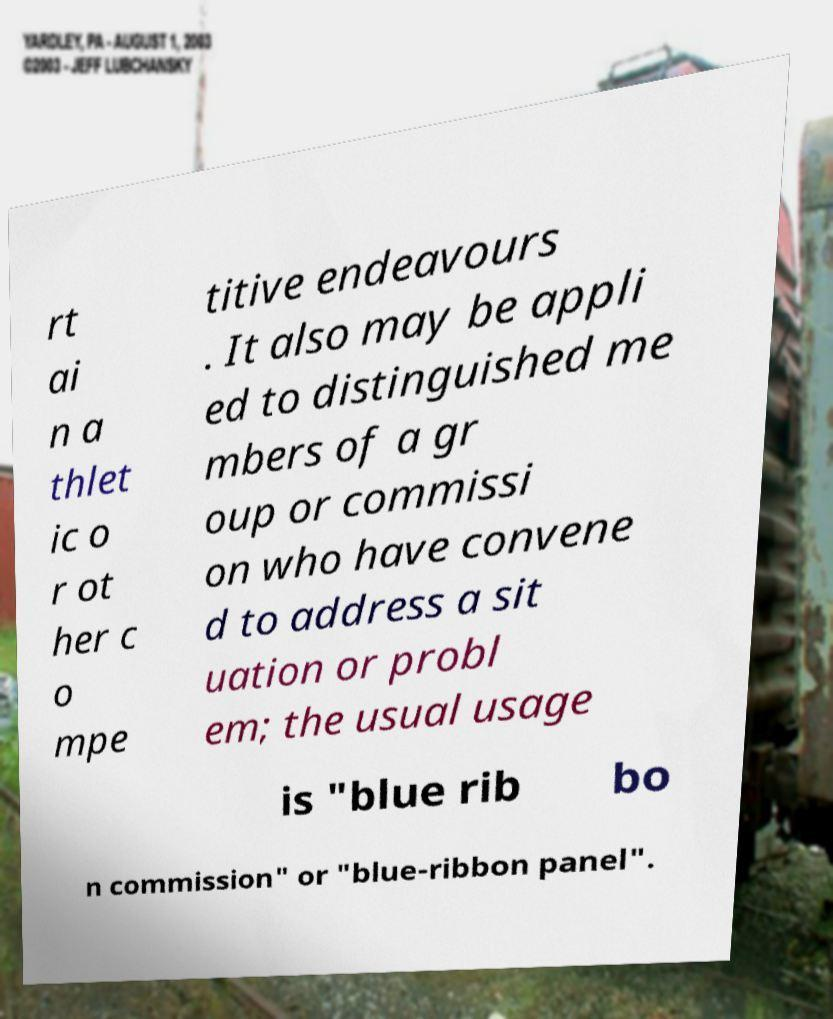I need the written content from this picture converted into text. Can you do that? rt ai n a thlet ic o r ot her c o mpe titive endeavours . It also may be appli ed to distinguished me mbers of a gr oup or commissi on who have convene d to address a sit uation or probl em; the usual usage is "blue rib bo n commission" or "blue-ribbon panel". 